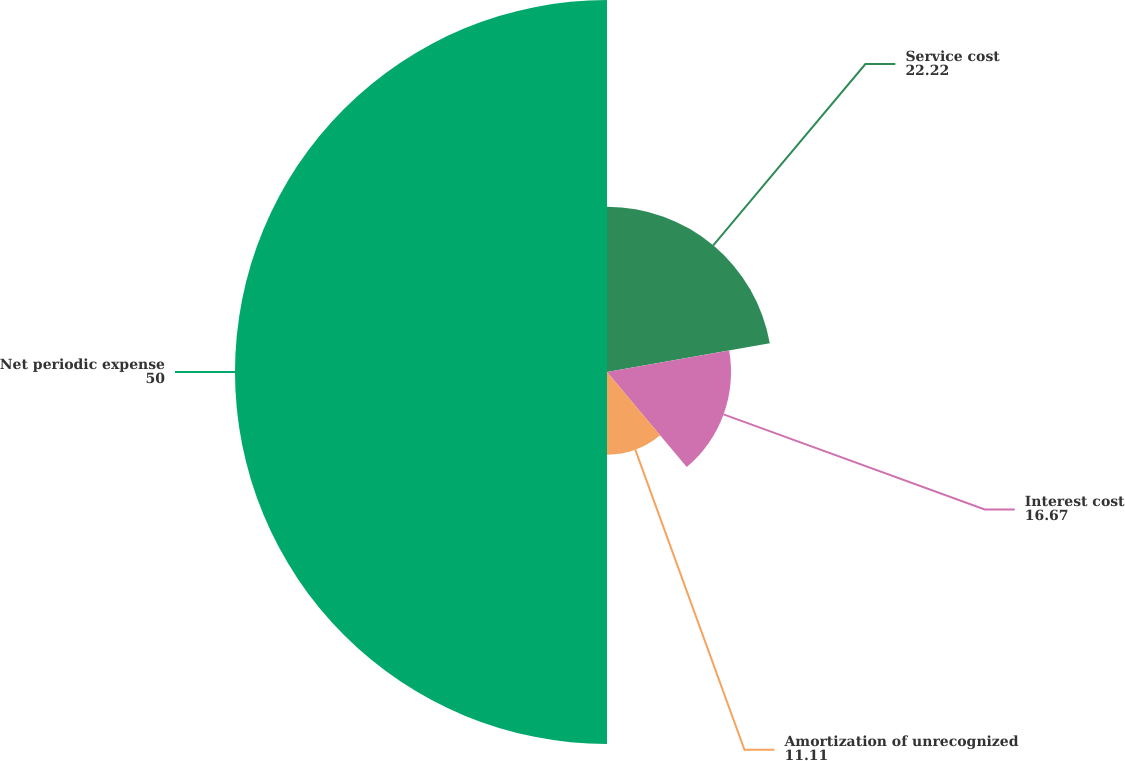Convert chart to OTSL. <chart><loc_0><loc_0><loc_500><loc_500><pie_chart><fcel>Service cost<fcel>Interest cost<fcel>Amortization of unrecognized<fcel>Net periodic expense<nl><fcel>22.22%<fcel>16.67%<fcel>11.11%<fcel>50.0%<nl></chart> 